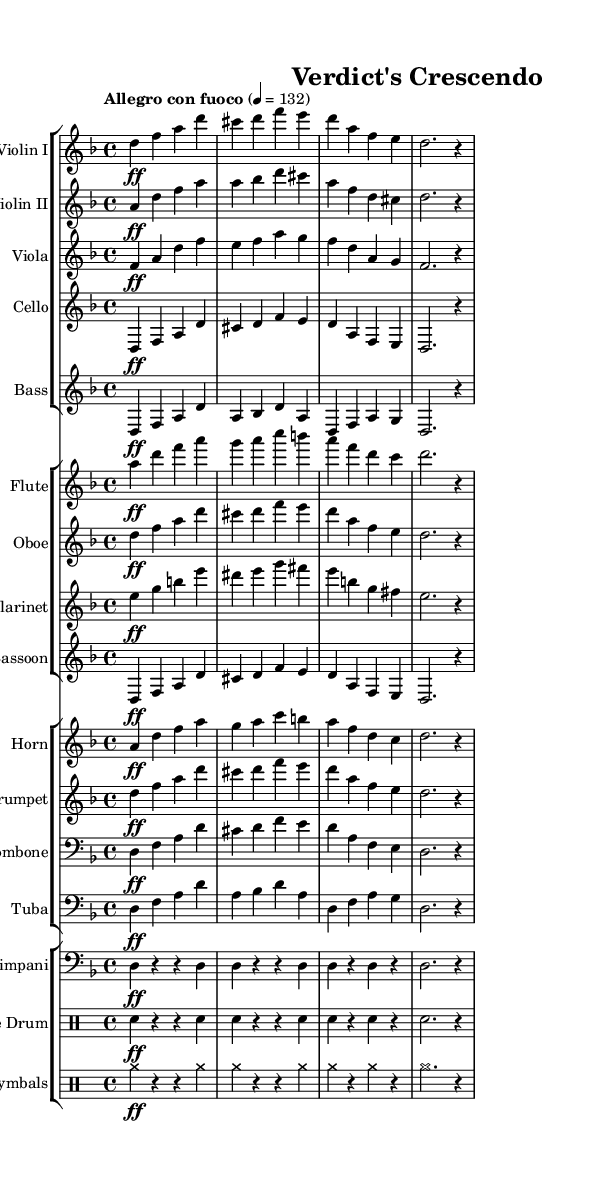What is the key signature of this music? The key signature is indicated by the sharps or flats present at the beginning of the staff. In this case, there are no sharps or flats in the key signature block, which tells us it is in D minor as deduced from the global declaration.
Answer: D minor What is the time signature of this music? The time signature is represented by two numbers at the beginning of the staff. Here, it shows 4/4, meaning there are four beats in each measure, and a quarter note gets one beat.
Answer: 4/4 What is the tempo marking of this piece? The tempo marking is found at the start and indicates the speed of the music. In this case, it states "Allegro con fuoco," which means fast with fire or intensity.
Answer: Allegro con fuoco How many instruments are used in this symphony? By examining the score, we can count the different staves and instrumental groups. There are five string instruments, four woodwinds, four brass, and two percussion staves, totaling fifteen instruments.
Answer: Fifteen What is the dynamic marking for the main themes in the string section? The dynamic markings indicate the volume of the notes. In the string sections, the dynamic marking is "ff," which means fortissimo, indicating a very loud dynamic.
Answer: ff Which percussion instrument is prominently featured in this piece? The percussion instruments are clearly labeled in the score. The timpani is represented in a specific staff, indicating its important role in developing rhythmic tension throughout the music.
Answer: Timpani What is the relationship between the first and second violins in this symphony? The first and second violins often play in harmony or counterpoint that enhances the overall texture. Here, both groups have complementary lines; while the first violin plays the principal melody, the second violin supplies harmonic support.
Answer: Complementary 